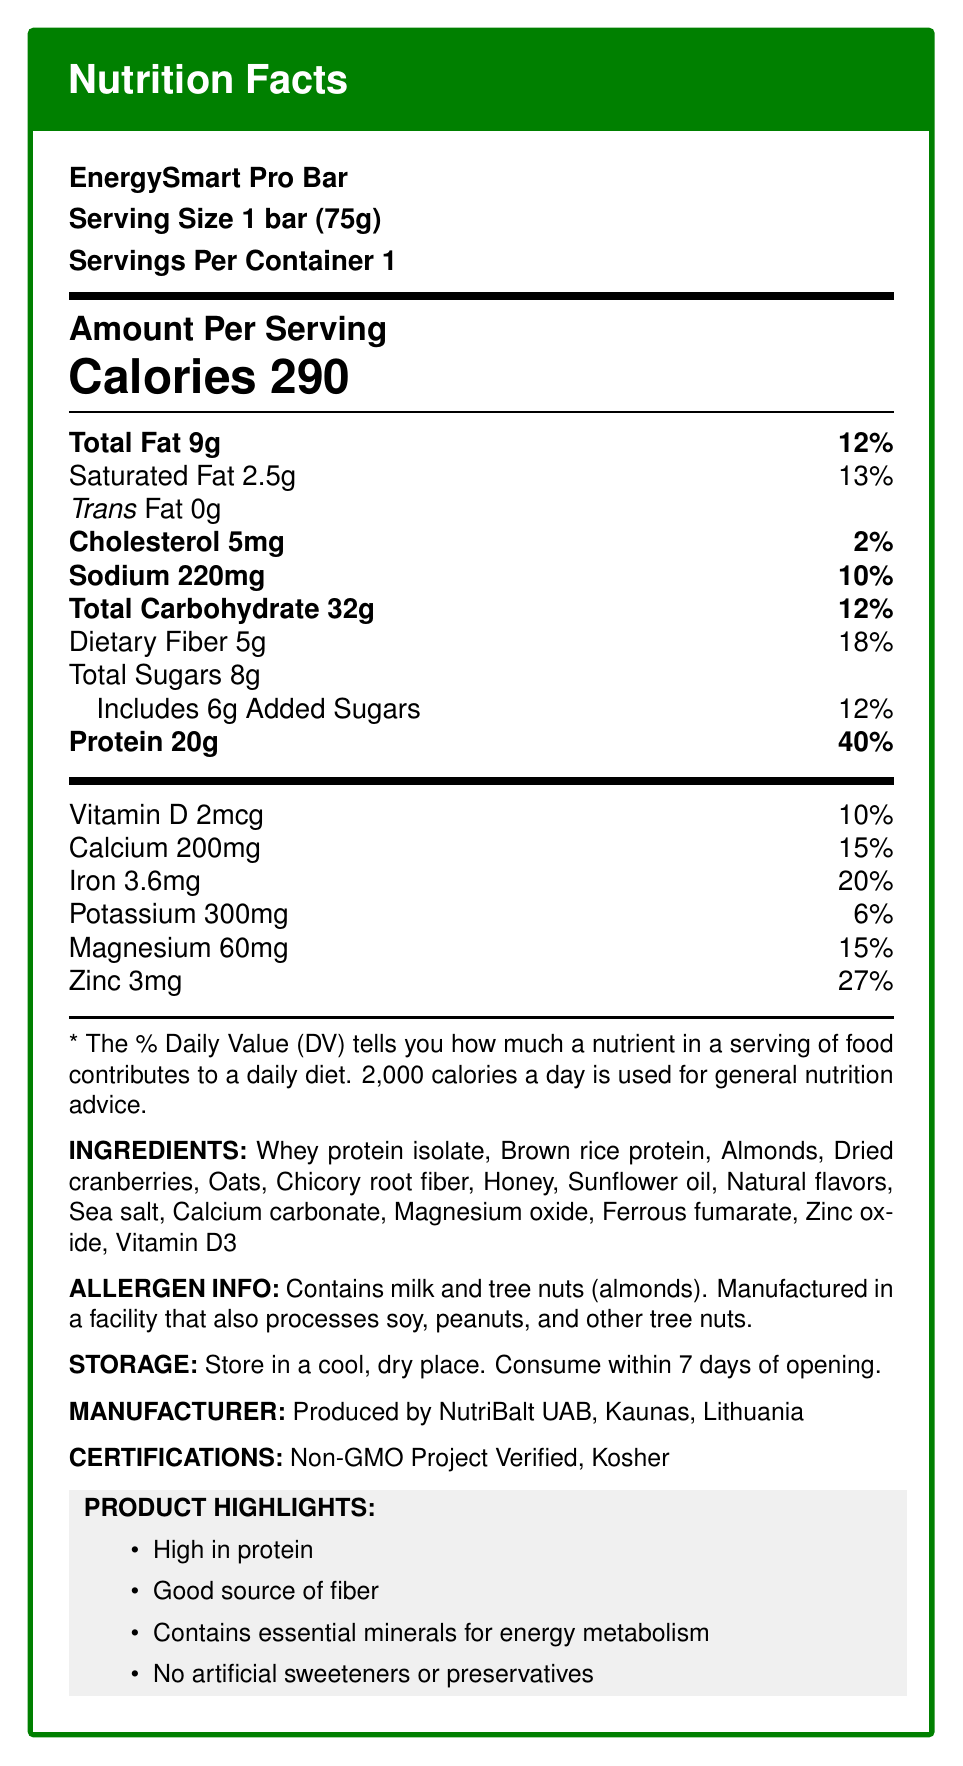What is the serving size of the EnergySmart Pro Bar? The serving size is listed as "1 bar (75g)" under the product name.
Answer: 1 bar (75g) How many calories are in one serving of the EnergySmart Pro Bar? The nutrition facts state "Calories 290" under the "Amount Per Serving" section.
Answer: 290 calories What percent of the Daily Value (%DV) does the Protein content contribute? Under the "Amount Per Serving" section, "Protein 20g" is listed with a daily value contribution of 40%.
Answer: 40% What are the main ingredients of the EnergySmart Pro Bar? The ingredients are listed under the "INGREDIENTS" section.
Answer: Whey protein isolate, Brown rice protein, Almonds, Dried cranberries, Oats, Chicory root fiber, Honey, Sunflower oil, Natural flavors, Sea salt, Calcium carbonate, Magnesium oxide, Ferrous fumarate, Zinc oxide, Vitamin D3 Where is the EnergySmart Pro Bar manufactured? The manufacturing information is found under the "MANUFACTURER" section.
Answer: Produced by NutriBalt UAB, Kaunas, Lithuania Which of the following vitamins and minerals does the bar contain? A. Vitamin A B. Vitamin D C. Vitamin K D. Vitamin B12 The nutrition facts list "Vitamin D 2mcg" with a daily value of 10%. There is no mention of Vitamin A, K, or B12.
Answer: B. Vitamin D What is the percentage daily value of Calcium in the bar? A. 5% B. 10% C. 15% D. 20% The daily value for Calcium is listed as 15% under the vitamins and minerals section.
Answer: C. 15% Does the EnergySmart Pro Bar contain any artificial sweeteners or preservatives? One of the product highlights mentions "No artificial sweeteners or preservatives."
Answer: No Is the EnergySmart Pro Bar a good source of fiber? Under product highlights, it states that the bar is a "Good source of fiber."
Answer: Yes Summarize the main idea of the document. The label details the nutritional content and components of the EnergySmart Pro Bar, emphasizes its health benefits and certifications, and provides manufacturing and storage information.
Answer: The Nutrition Facts Label of the EnergySmart Pro Bar provides detailed nutritional information, listing ingredients, allergen information, storage instructions, and certifications. It highlights the high protein content, beneficial fiber, and essential minerals for energy metabolism, while assuring no artificial sweeteners or preservatives. What is the main protein source in the EnergySmart Pro Bar? The main ingredient listed is "Whey protein isolate," indicating it is the primary protein source.
Answer: Whey protein isolate How many grams of dietary fiber does the EnergySmart Pro Bar contain? The nutrition facts indicate that the bar contains "Dietary Fiber 5g."
Answer: 5g What is the product highlight that mentions minerals? One of the product highlights reads "Contains essential minerals for energy metabolism."
Answer: Contains essential minerals for energy metabolism Could someone with a peanut allergy safely consume the EnergySmart Pro Bar? While the bar does not list peanuts as an ingredient, it is processed in a facility that may process peanuts, so cross-contamination is possible.
Answer: Not enough information What minerals are present in the EnergySmart Pro Bar? The vitamins and minerals listed include Calcium (200mg), Iron (3.6mg), Potassium (300mg), Magnesium (60mg), and Zinc (3mg).
Answer: Calcium, Iron, Potassium, Magnesium, Zinc 